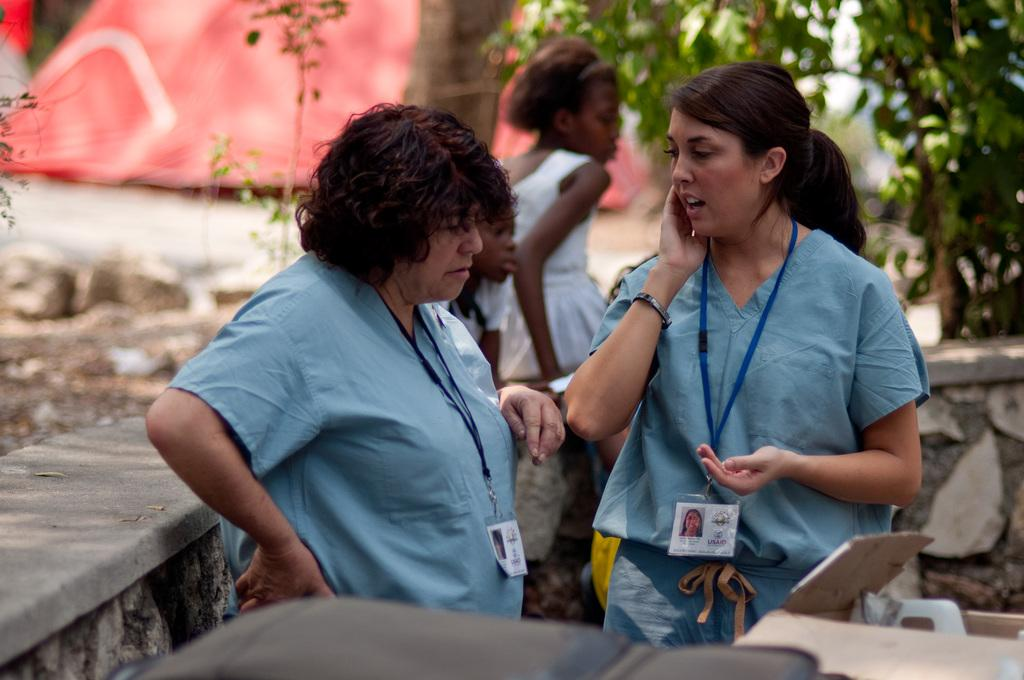What can be seen in the image? There are women standing in the image. What is visible in the background of the image? There is a wall and trees in the background of the image. What type of store can be seen in the image? There is no store present in the image; it features women standing in front of a wall and trees. What color is the head of the woman on the left? The provided facts do not mention the color of the women's heads, so it cannot be determined from the image. 